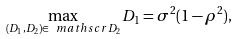<formula> <loc_0><loc_0><loc_500><loc_500>\max _ { ( D _ { 1 } , D _ { 2 } ) \in \ m a t h s c r { D } _ { 2 } } D _ { 1 } = \sigma ^ { 2 } ( 1 - \rho ^ { 2 } ) ,</formula> 